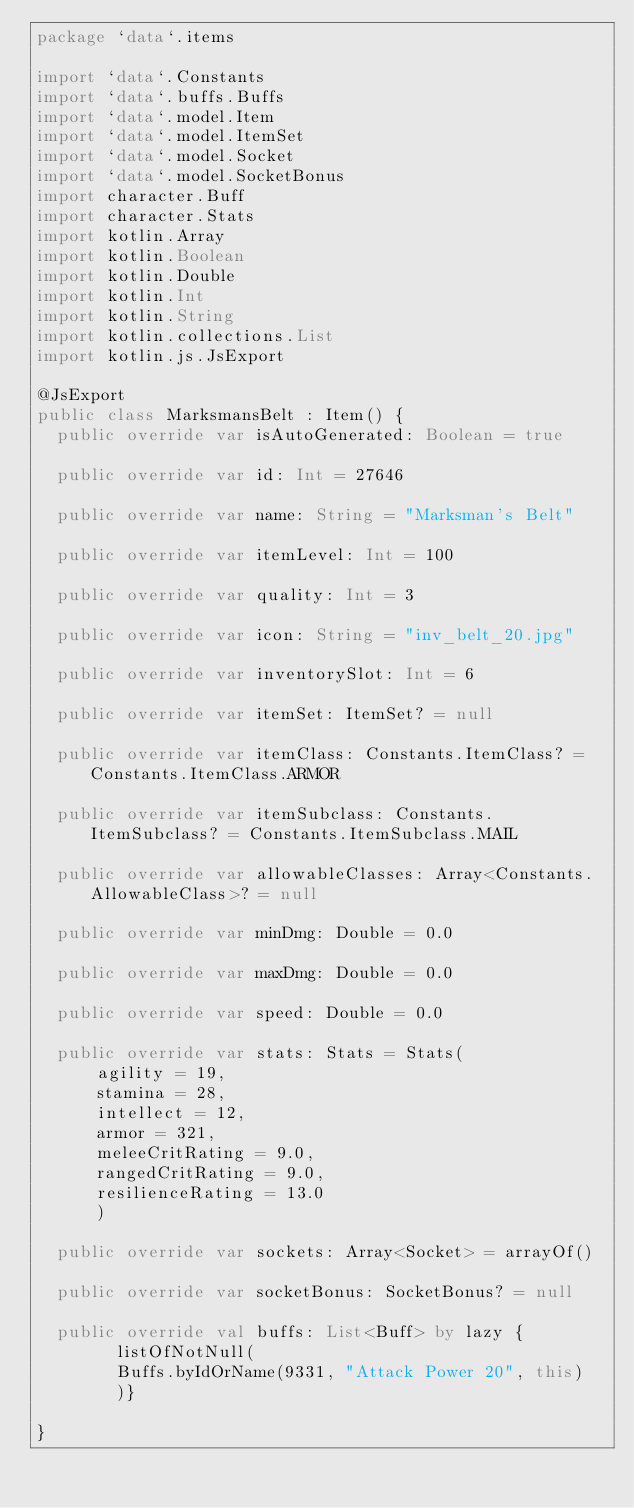Convert code to text. <code><loc_0><loc_0><loc_500><loc_500><_Kotlin_>package `data`.items

import `data`.Constants
import `data`.buffs.Buffs
import `data`.model.Item
import `data`.model.ItemSet
import `data`.model.Socket
import `data`.model.SocketBonus
import character.Buff
import character.Stats
import kotlin.Array
import kotlin.Boolean
import kotlin.Double
import kotlin.Int
import kotlin.String
import kotlin.collections.List
import kotlin.js.JsExport

@JsExport
public class MarksmansBelt : Item() {
  public override var isAutoGenerated: Boolean = true

  public override var id: Int = 27646

  public override var name: String = "Marksman's Belt"

  public override var itemLevel: Int = 100

  public override var quality: Int = 3

  public override var icon: String = "inv_belt_20.jpg"

  public override var inventorySlot: Int = 6

  public override var itemSet: ItemSet? = null

  public override var itemClass: Constants.ItemClass? = Constants.ItemClass.ARMOR

  public override var itemSubclass: Constants.ItemSubclass? = Constants.ItemSubclass.MAIL

  public override var allowableClasses: Array<Constants.AllowableClass>? = null

  public override var minDmg: Double = 0.0

  public override var maxDmg: Double = 0.0

  public override var speed: Double = 0.0

  public override var stats: Stats = Stats(
      agility = 19,
      stamina = 28,
      intellect = 12,
      armor = 321,
      meleeCritRating = 9.0,
      rangedCritRating = 9.0,
      resilienceRating = 13.0
      )

  public override var sockets: Array<Socket> = arrayOf()

  public override var socketBonus: SocketBonus? = null

  public override val buffs: List<Buff> by lazy {
        listOfNotNull(
        Buffs.byIdOrName(9331, "Attack Power 20", this)
        )}

}
</code> 